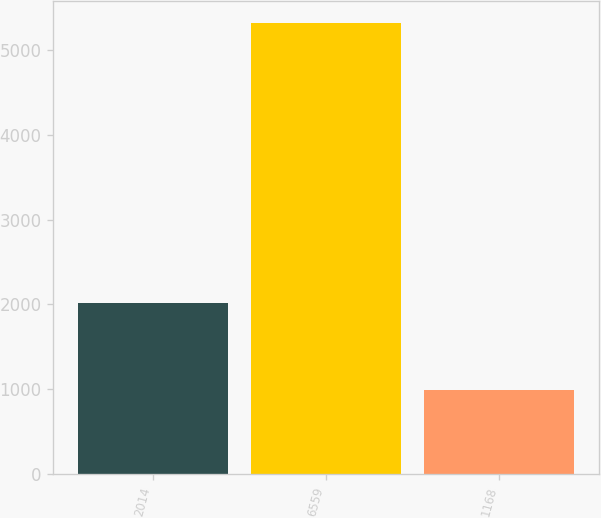Convert chart to OTSL. <chart><loc_0><loc_0><loc_500><loc_500><bar_chart><fcel>2014<fcel>6559<fcel>1168<nl><fcel>2012<fcel>5315<fcel>992<nl></chart> 